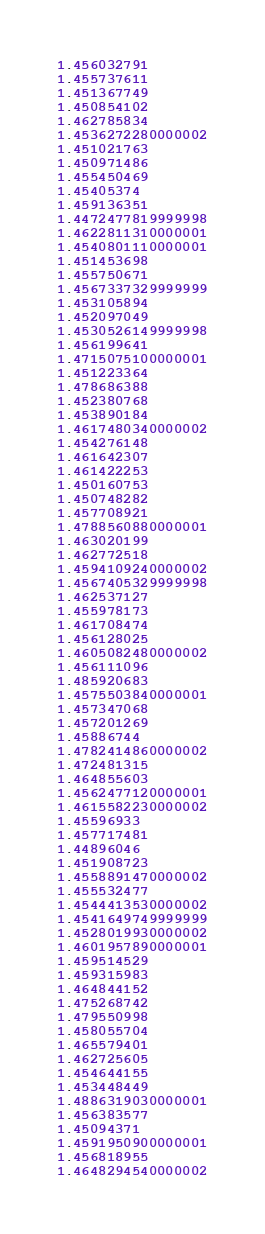Convert code to text. <code><loc_0><loc_0><loc_500><loc_500><_SQL_>1.456032791
1.455737611
1.451367749
1.450854102
1.462785834
1.4536272280000002
1.451021763
1.450971486
1.455450469
1.45405374
1.459136351
1.4472477819999998
1.4622811310000001
1.4540801110000001
1.451453698
1.455750671
1.4567337329999999
1.453105894
1.452097049
1.4530526149999998
1.456199641
1.4715075100000001
1.451223364
1.478686388
1.452380768
1.453890184
1.4617480340000002
1.454276148
1.461642307
1.461422253
1.450160753
1.450748282
1.457708921
1.4788560880000001
1.463020199
1.462772518
1.4594109240000002
1.4567405329999998
1.462537127
1.455978173
1.461708474
1.456128025
1.4605082480000002
1.456111096
1.485920683
1.4575503840000001
1.457347068
1.457201269
1.45886744
1.4782414860000002
1.472481315
1.464855603
1.4562477120000001
1.4615582230000002
1.45596933
1.457717481
1.44896046
1.451908723
1.4558891470000002
1.455532477
1.4544413530000002
1.4541649749999999
1.4528019930000002
1.4601957890000001
1.459514529
1.459315983
1.464844152
1.475268742
1.479550998
1.458055704
1.465579401
1.462725605
1.454644155
1.453448449
1.4886319030000001
1.456383577
1.45094371
1.4591950900000001
1.456818955
1.4648294540000002
</code> 